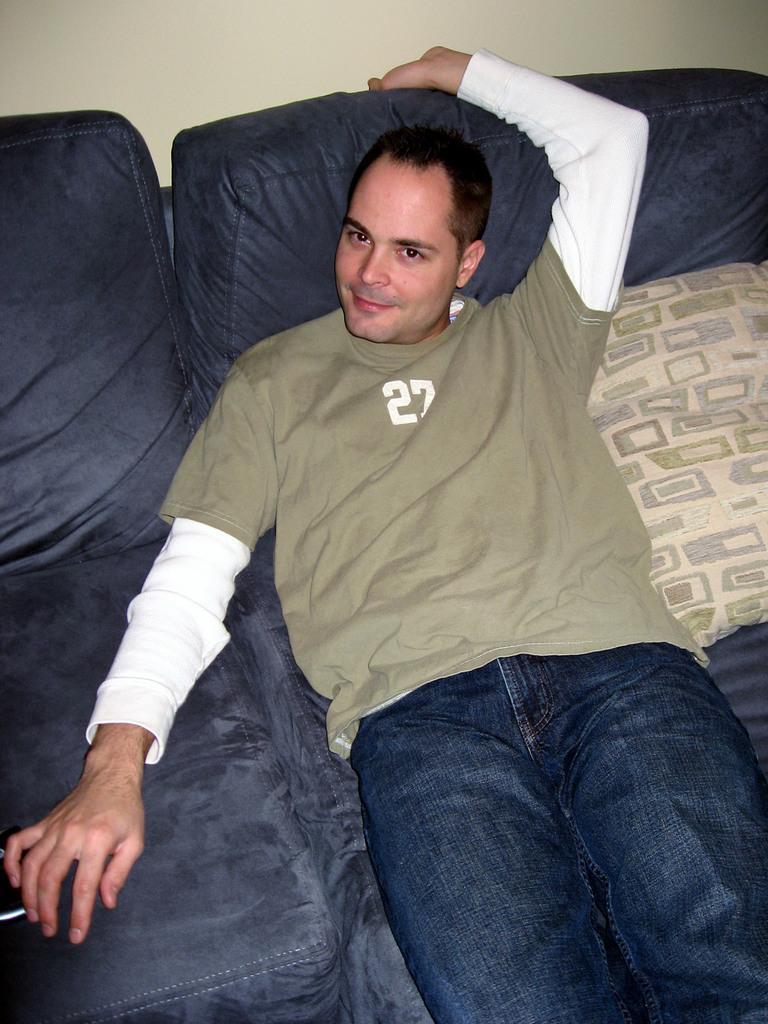Can you describe this image briefly? In this image I can see a person is lying on a bed, cushions and a wall. This image is taken may be in a room. 